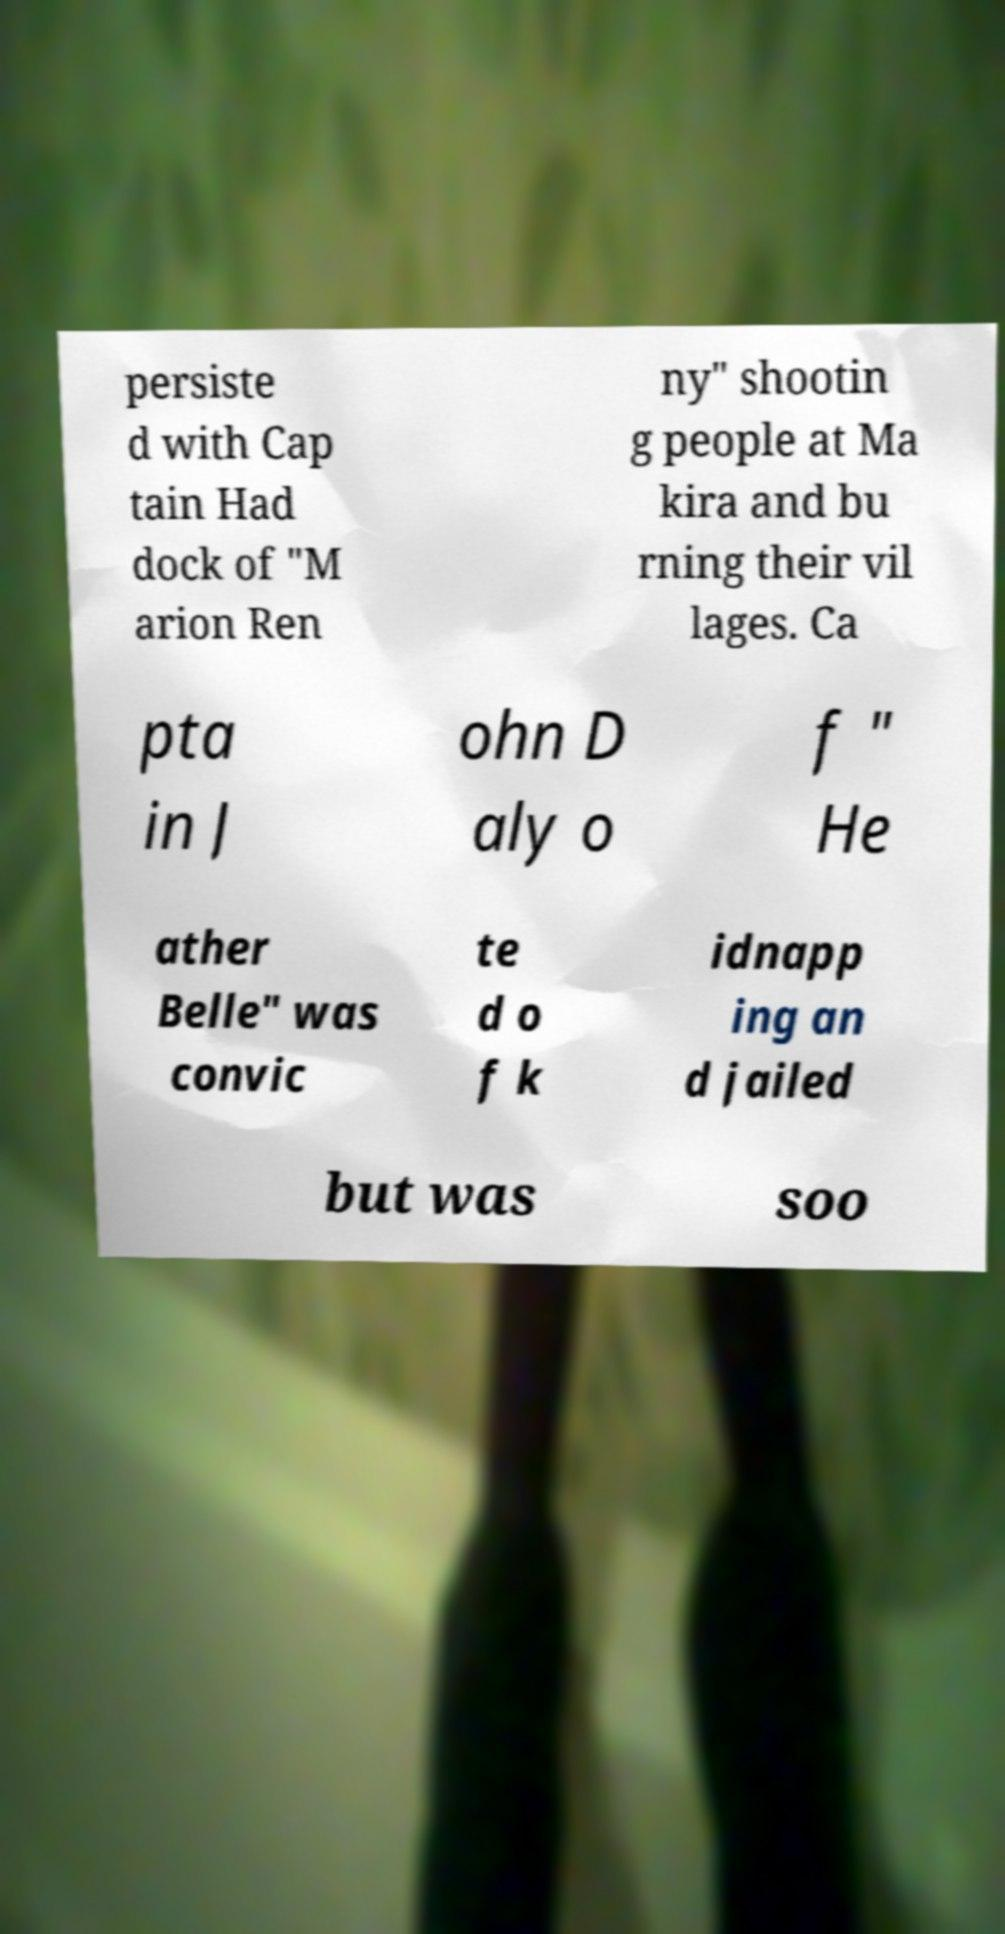There's text embedded in this image that I need extracted. Can you transcribe it verbatim? persiste d with Cap tain Had dock of "M arion Ren ny" shootin g people at Ma kira and bu rning their vil lages. Ca pta in J ohn D aly o f " He ather Belle" was convic te d o f k idnapp ing an d jailed but was soo 